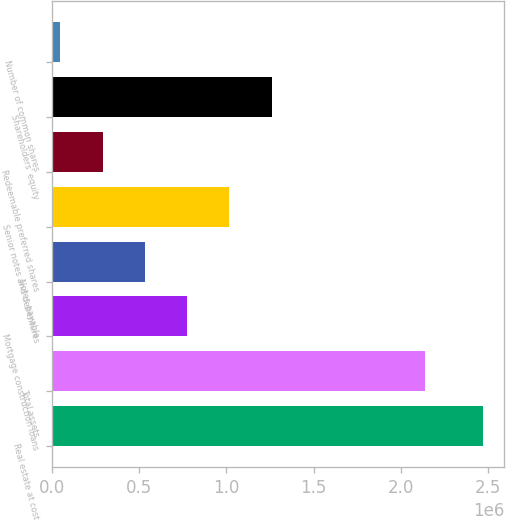Convert chart to OTSL. <chart><loc_0><loc_0><loc_500><loc_500><bar_chart><fcel>Real estate at cost<fcel>Total assets<fcel>Mortgage construction loans<fcel>Notes payable<fcel>Senior notes and debentures<fcel>Redeemable preferred shares<fcel>Shareholders' equity<fcel>Number of common shares<nl><fcel>2.47015e+06<fcel>2.14118e+06<fcel>775485<fcel>533391<fcel>1.01758e+06<fcel>291296<fcel>1.25968e+06<fcel>49201<nl></chart> 